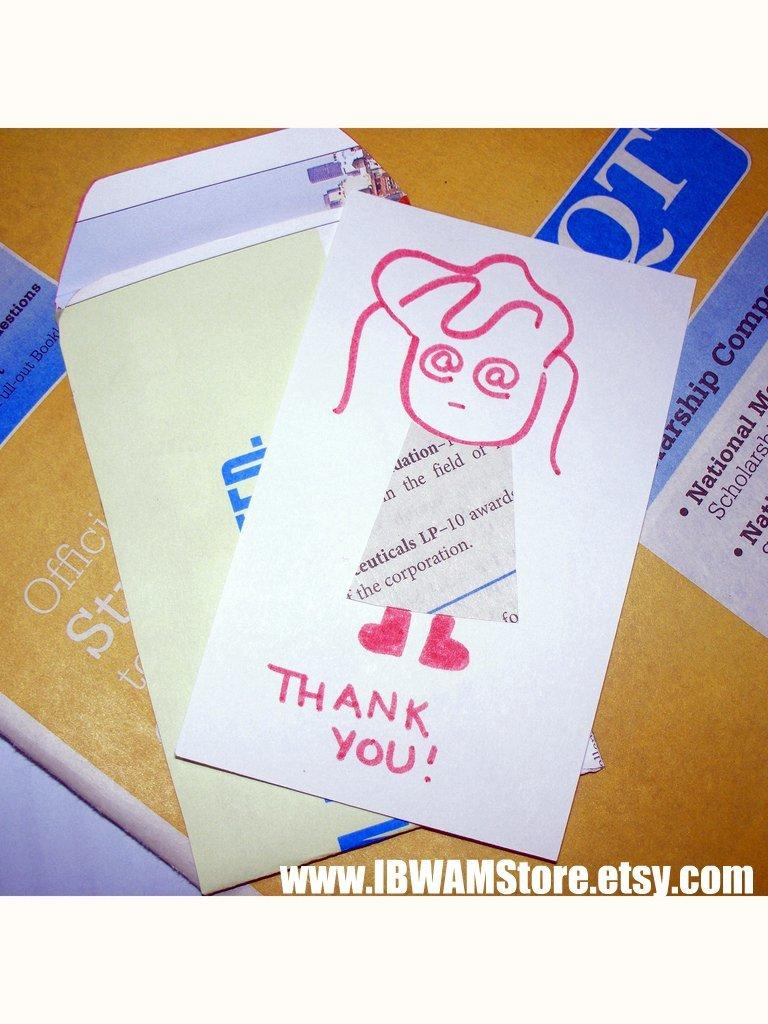<image>
Summarize the visual content of the image. A hand drawn Thank You note depicting a girl with a newspaper dress. 